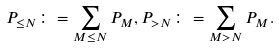<formula> <loc_0><loc_0><loc_500><loc_500>P _ { \leq N } \colon = \sum _ { M \leq N } P _ { M } , P _ { > N } \colon = \sum _ { M > N } P _ { M } .</formula> 